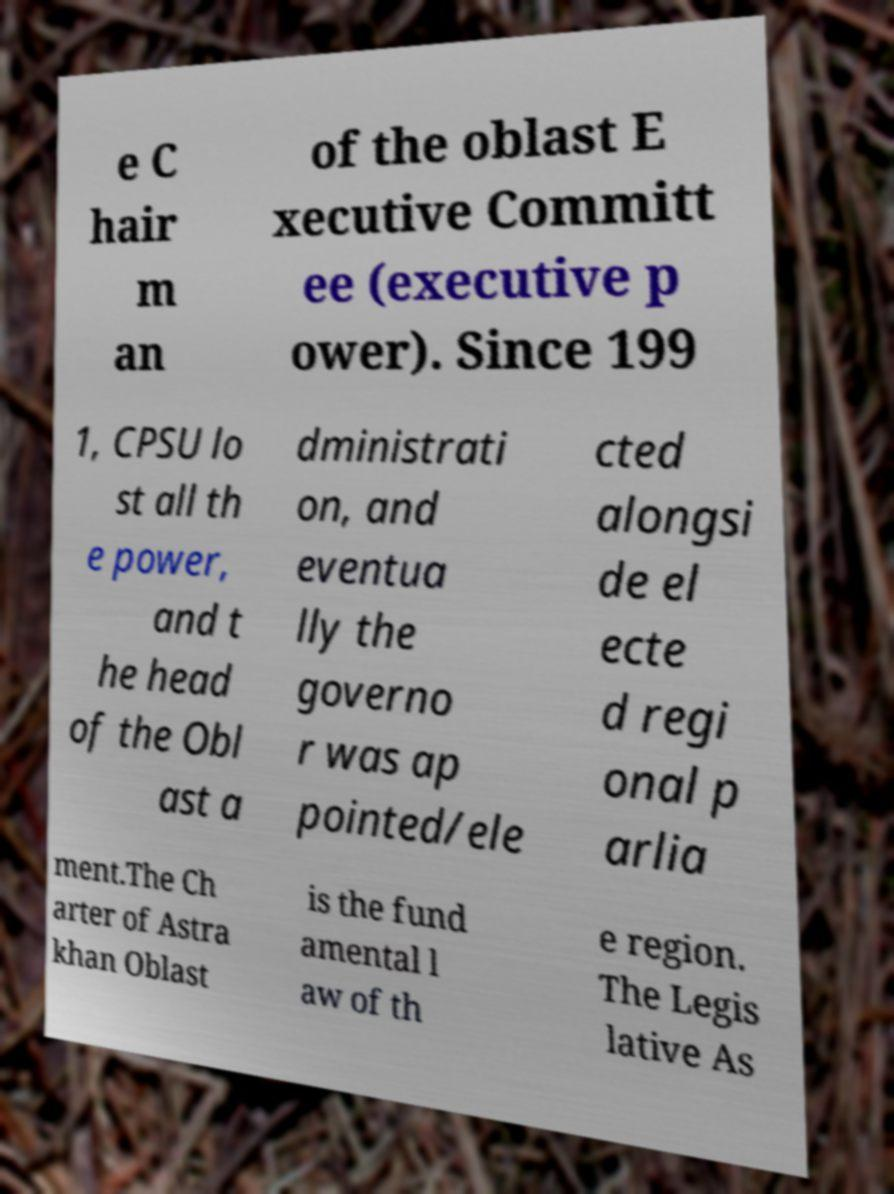For documentation purposes, I need the text within this image transcribed. Could you provide that? e C hair m an of the oblast E xecutive Committ ee (executive p ower). Since 199 1, CPSU lo st all th e power, and t he head of the Obl ast a dministrati on, and eventua lly the governo r was ap pointed/ele cted alongsi de el ecte d regi onal p arlia ment.The Ch arter of Astra khan Oblast is the fund amental l aw of th e region. The Legis lative As 